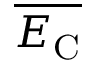<formula> <loc_0><loc_0><loc_500><loc_500>\overline { { E _ { C } } }</formula> 